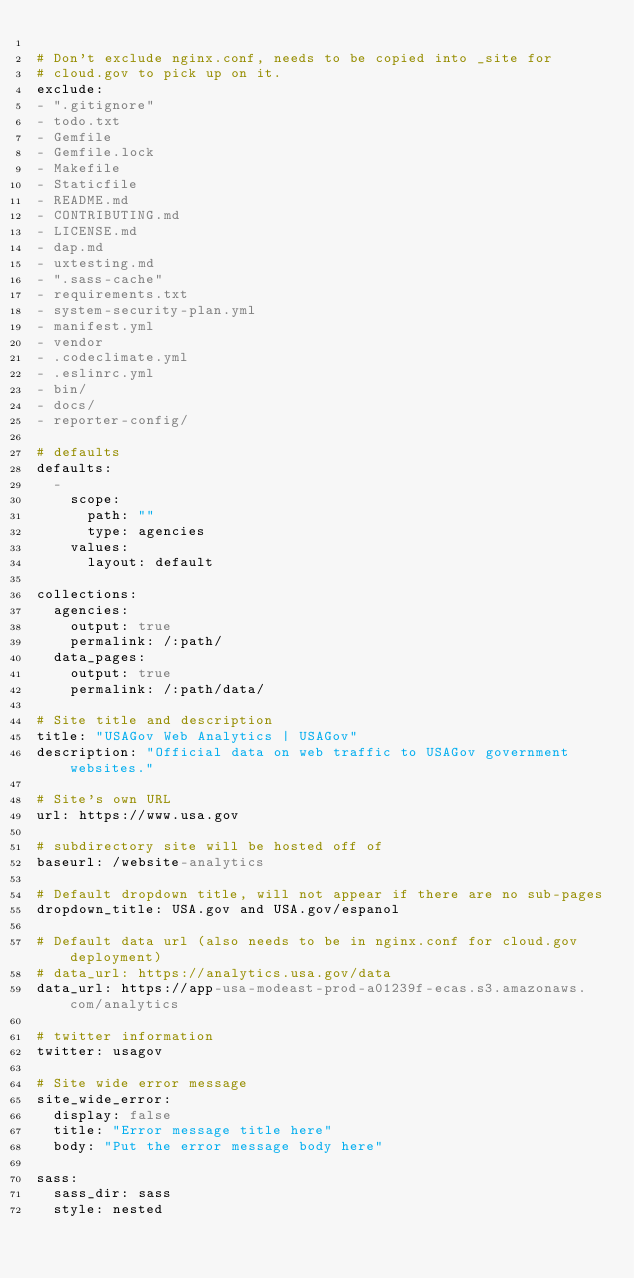<code> <loc_0><loc_0><loc_500><loc_500><_YAML_>
# Don't exclude nginx.conf, needs to be copied into _site for
# cloud.gov to pick up on it.
exclude:
- ".gitignore"
- todo.txt
- Gemfile
- Gemfile.lock
- Makefile
- Staticfile
- README.md
- CONTRIBUTING.md
- LICENSE.md
- dap.md
- uxtesting.md
- ".sass-cache"
- requirements.txt
- system-security-plan.yml
- manifest.yml
- vendor
- .codeclimate.yml
- .eslinrc.yml
- bin/
- docs/
- reporter-config/

# defaults
defaults:
  -
    scope:
      path: ""
      type: agencies
    values:
      layout: default

collections:
  agencies:
    output: true
    permalink: /:path/
  data_pages:
    output: true
    permalink: /:path/data/

# Site title and description
title: "USAGov Web Analytics | USAGov"
description: "Official data on web traffic to USAGov government websites."

# Site's own URL
url: https://www.usa.gov

# subdirectory site will be hosted off of
baseurl: /website-analytics

# Default dropdown title, will not appear if there are no sub-pages
dropdown_title: USA.gov and USA.gov/espanol

# Default data url (also needs to be in nginx.conf for cloud.gov deployment)
# data_url: https://analytics.usa.gov/data
data_url: https://app-usa-modeast-prod-a01239f-ecas.s3.amazonaws.com/analytics

# twitter information
twitter: usagov

# Site wide error message
site_wide_error:
  display: false
  title: "Error message title here"
  body: "Put the error message body here"

sass:
  sass_dir: sass
  style: nested
</code> 